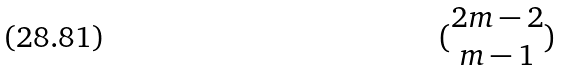<formula> <loc_0><loc_0><loc_500><loc_500>( \begin{matrix} 2 m - 2 \\ m - 1 \end{matrix} )</formula> 